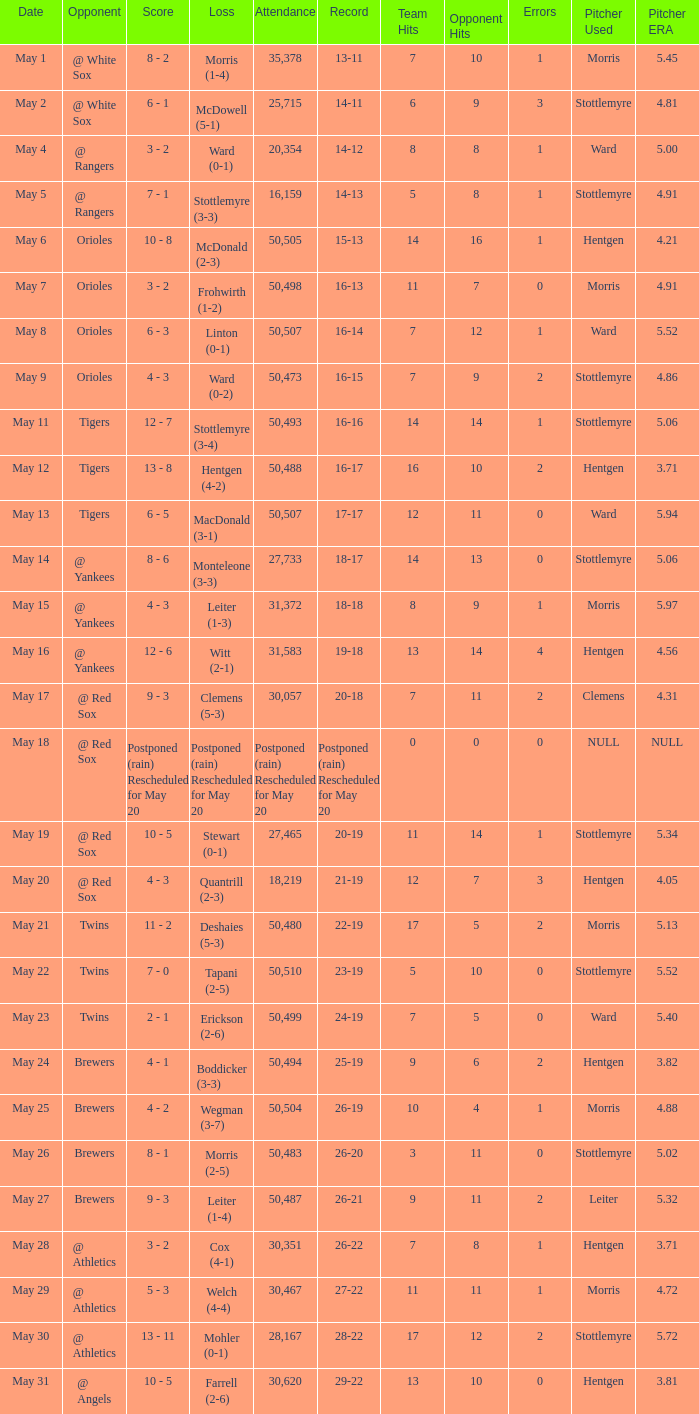I'm looking to parse the entire table for insights. Could you assist me with that? {'header': ['Date', 'Opponent', 'Score', 'Loss', 'Attendance', 'Record', 'Team Hits', 'Opponent Hits', 'Errors', 'Pitcher Used', 'Pitcher ERA'], 'rows': [['May 1', '@ White Sox', '8 - 2', 'Morris (1-4)', '35,378', '13-11', '7', '10', '1', 'Morris', '5.45'], ['May 2', '@ White Sox', '6 - 1', 'McDowell (5-1)', '25,715', '14-11', '6', '9', '3', 'Stottlemyre', '4.81'], ['May 4', '@ Rangers', '3 - 2', 'Ward (0-1)', '20,354', '14-12', '8', '8', '1', 'Ward', '5.00'], ['May 5', '@ Rangers', '7 - 1', 'Stottlemyre (3-3)', '16,159', '14-13', '5', '8', '1', 'Stottlemyre', '4.91'], ['May 6', 'Orioles', '10 - 8', 'McDonald (2-3)', '50,505', '15-13', '14', '16', '1', 'Hentgen', '4.21'], ['May 7', 'Orioles', '3 - 2', 'Frohwirth (1-2)', '50,498', '16-13', '11', '7', '0', 'Morris', '4.91'], ['May 8', 'Orioles', '6 - 3', 'Linton (0-1)', '50,507', '16-14', '7', '12', '1', 'Ward', '5.52'], ['May 9', 'Orioles', '4 - 3', 'Ward (0-2)', '50,473', '16-15', '7', '9', '2', 'Stottlemyre', '4.86'], ['May 11', 'Tigers', '12 - 7', 'Stottlemyre (3-4)', '50,493', '16-16', '14', '14', '1', 'Stottlemyre', '5.06'], ['May 12', 'Tigers', '13 - 8', 'Hentgen (4-2)', '50,488', '16-17', '16', '10', '2', 'Hentgen', '3.71'], ['May 13', 'Tigers', '6 - 5', 'MacDonald (3-1)', '50,507', '17-17', '12', '11', '0', 'Ward', '5.94'], ['May 14', '@ Yankees', '8 - 6', 'Monteleone (3-3)', '27,733', '18-17', '14', '13', '0', 'Stottlemyre', '5.06'], ['May 15', '@ Yankees', '4 - 3', 'Leiter (1-3)', '31,372', '18-18', '8', '9', '1', 'Morris', '5.97'], ['May 16', '@ Yankees', '12 - 6', 'Witt (2-1)', '31,583', '19-18', '13', '14', '4', 'Hentgen', '4.56'], ['May 17', '@ Red Sox', '9 - 3', 'Clemens (5-3)', '30,057', '20-18', '7', '11', '2', 'Clemens', '4.31'], ['May 18', '@ Red Sox', 'Postponed (rain) Rescheduled for May 20', 'Postponed (rain) Rescheduled for May 20', 'Postponed (rain) Rescheduled for May 20', 'Postponed (rain) Rescheduled for May 20', '0', '0', '0', 'NULL', 'NULL'], ['May 19', '@ Red Sox', '10 - 5', 'Stewart (0-1)', '27,465', '20-19', '11', '14', '1', 'Stottlemyre', '5.34'], ['May 20', '@ Red Sox', '4 - 3', 'Quantrill (2-3)', '18,219', '21-19', '12', '7', '3', 'Hentgen', '4.05'], ['May 21', 'Twins', '11 - 2', 'Deshaies (5-3)', '50,480', '22-19', '17', '5', '2', 'Morris', '5.13'], ['May 22', 'Twins', '7 - 0', 'Tapani (2-5)', '50,510', '23-19', '5', '10', '0', 'Stottlemyre', '5.52'], ['May 23', 'Twins', '2 - 1', 'Erickson (2-6)', '50,499', '24-19', '7', '5', '0', 'Ward', '5.40'], ['May 24', 'Brewers', '4 - 1', 'Boddicker (3-3)', '50,494', '25-19', '9', '6', '2', 'Hentgen', '3.82'], ['May 25', 'Brewers', '4 - 2', 'Wegman (3-7)', '50,504', '26-19', '10', '4', '1', 'Morris', '4.88'], ['May 26', 'Brewers', '8 - 1', 'Morris (2-5)', '50,483', '26-20', '3', '11', '0', 'Stottlemyre', '5.02'], ['May 27', 'Brewers', '9 - 3', 'Leiter (1-4)', '50,487', '26-21', '9', '11', '2', 'Leiter', '5.32'], ['May 28', '@ Athletics', '3 - 2', 'Cox (4-1)', '30,351', '26-22', '7', '8', '1', 'Hentgen', '3.71'], ['May 29', '@ Athletics', '5 - 3', 'Welch (4-4)', '30,467', '27-22', '11', '11', '1', 'Morris', '4.72'], ['May 30', '@ Athletics', '13 - 11', 'Mohler (0-1)', '28,167', '28-22', '17', '12', '2', 'Stottlemyre', '5.72'], ['May 31', '@ Angels', '10 - 5', 'Farrell (2-6)', '30,620', '29-22', '13', '10', '0', 'Hentgen', '3.81']]} What team did they lose to when they had a 28-22 record? Mohler (0-1). 